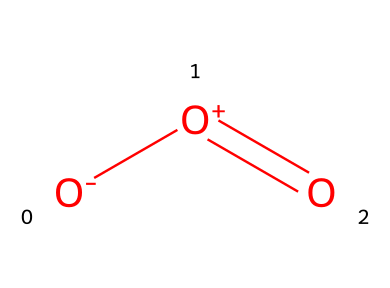What is the molecular formula for ozone? The SMILES representation indicates there are three oxygen atoms present, as inferred from the [O-][O+]=O structure showing three connected oxygen atoms.
Answer: O3 How many bonds are present in the ozone molecule? In the SMILES representation, there are two types of bonds: one double bond between [O+]=O and one single bond between [O-] and [O+]. Counting these gives a total of three bonds.
Answer: 3 What is the charge on the central oxygen atom in ozone? From the SMILES notation, the central oxygen atom has a positive charge, indicated by the [O+] symbol.
Answer: positive What is the shape of the ozone molecule? Ozone has a bent shape due to its angular arrangement resulting from the repulsion of the lone pairs on the oxygen atoms, which can be inferred from its structure.
Answer: bent Is ozone a gas at room temperature? Ozone is classified as a gas, as indicated by its presence in the gaseous state in the atmosphere, particularly in the troposphere.
Answer: yes What makes ozone a significant gas in the atmosphere? Ozone is significant due to its role in absorbing harmful UV radiation from the sun, as well as being a key component of air pollution in the troposphere.
Answer: UV absorption 